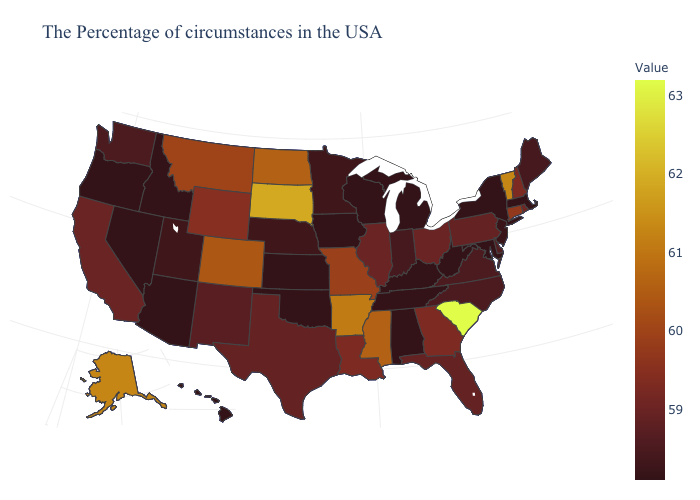Among the states that border Kentucky , which have the highest value?
Give a very brief answer. Missouri. Which states have the highest value in the USA?
Write a very short answer. South Carolina. Does South Carolina have the highest value in the USA?
Short answer required. Yes. Among the states that border Mississippi , does Alabama have the highest value?
Keep it brief. No. Does the map have missing data?
Keep it brief. No. Does Colorado have the highest value in the West?
Short answer required. No. Does Arkansas have the lowest value in the USA?
Be succinct. No. Which states have the lowest value in the South?
Short answer required. Maryland, West Virginia, Kentucky, Alabama, Tennessee, Oklahoma. Among the states that border Georgia , does Alabama have the highest value?
Answer briefly. No. 